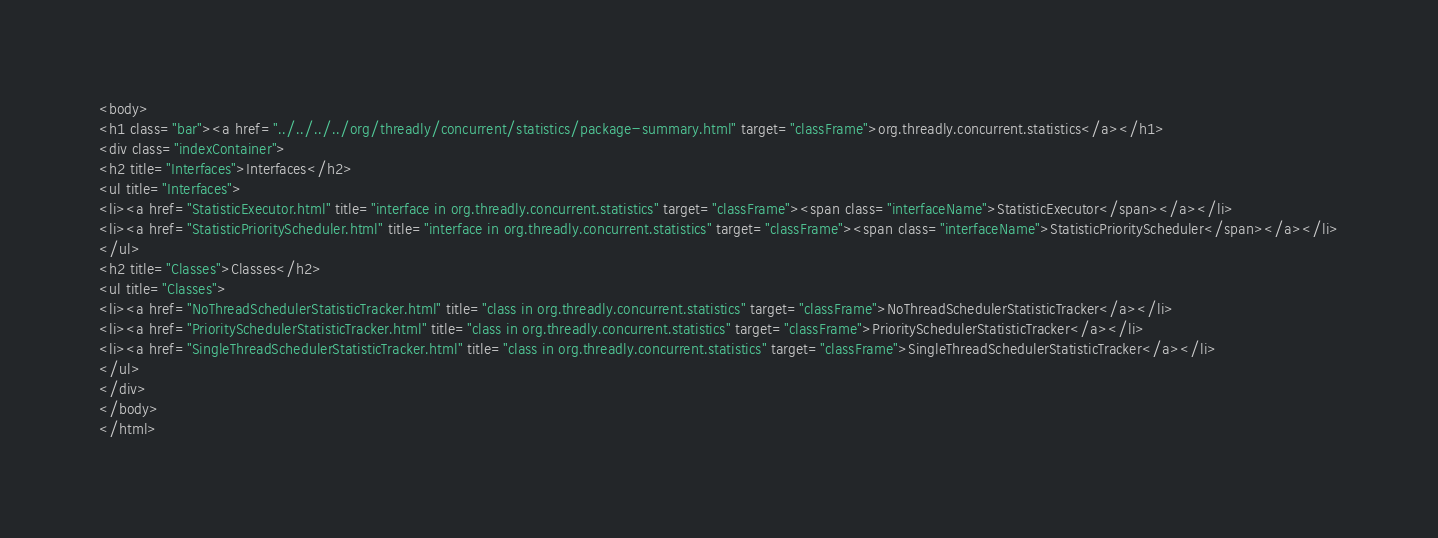<code> <loc_0><loc_0><loc_500><loc_500><_HTML_><body>
<h1 class="bar"><a href="../../../../org/threadly/concurrent/statistics/package-summary.html" target="classFrame">org.threadly.concurrent.statistics</a></h1>
<div class="indexContainer">
<h2 title="Interfaces">Interfaces</h2>
<ul title="Interfaces">
<li><a href="StatisticExecutor.html" title="interface in org.threadly.concurrent.statistics" target="classFrame"><span class="interfaceName">StatisticExecutor</span></a></li>
<li><a href="StatisticPriorityScheduler.html" title="interface in org.threadly.concurrent.statistics" target="classFrame"><span class="interfaceName">StatisticPriorityScheduler</span></a></li>
</ul>
<h2 title="Classes">Classes</h2>
<ul title="Classes">
<li><a href="NoThreadSchedulerStatisticTracker.html" title="class in org.threadly.concurrent.statistics" target="classFrame">NoThreadSchedulerStatisticTracker</a></li>
<li><a href="PrioritySchedulerStatisticTracker.html" title="class in org.threadly.concurrent.statistics" target="classFrame">PrioritySchedulerStatisticTracker</a></li>
<li><a href="SingleThreadSchedulerStatisticTracker.html" title="class in org.threadly.concurrent.statistics" target="classFrame">SingleThreadSchedulerStatisticTracker</a></li>
</ul>
</div>
</body>
</html>
</code> 